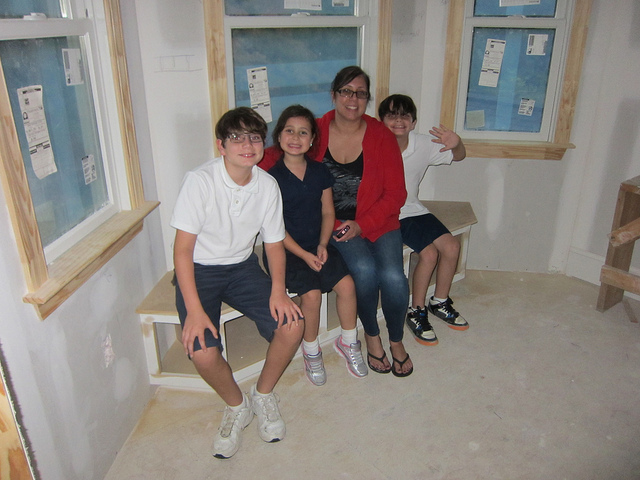<image>Is the floor made of tile or linoleum? It is uncertain if the floor is made of tile or linoleum. The material could be either of the two. Is the floor made of tile or linoleum? I am not sure if the floor is made of tile or linoleum. It can be either tile or linoleum. 